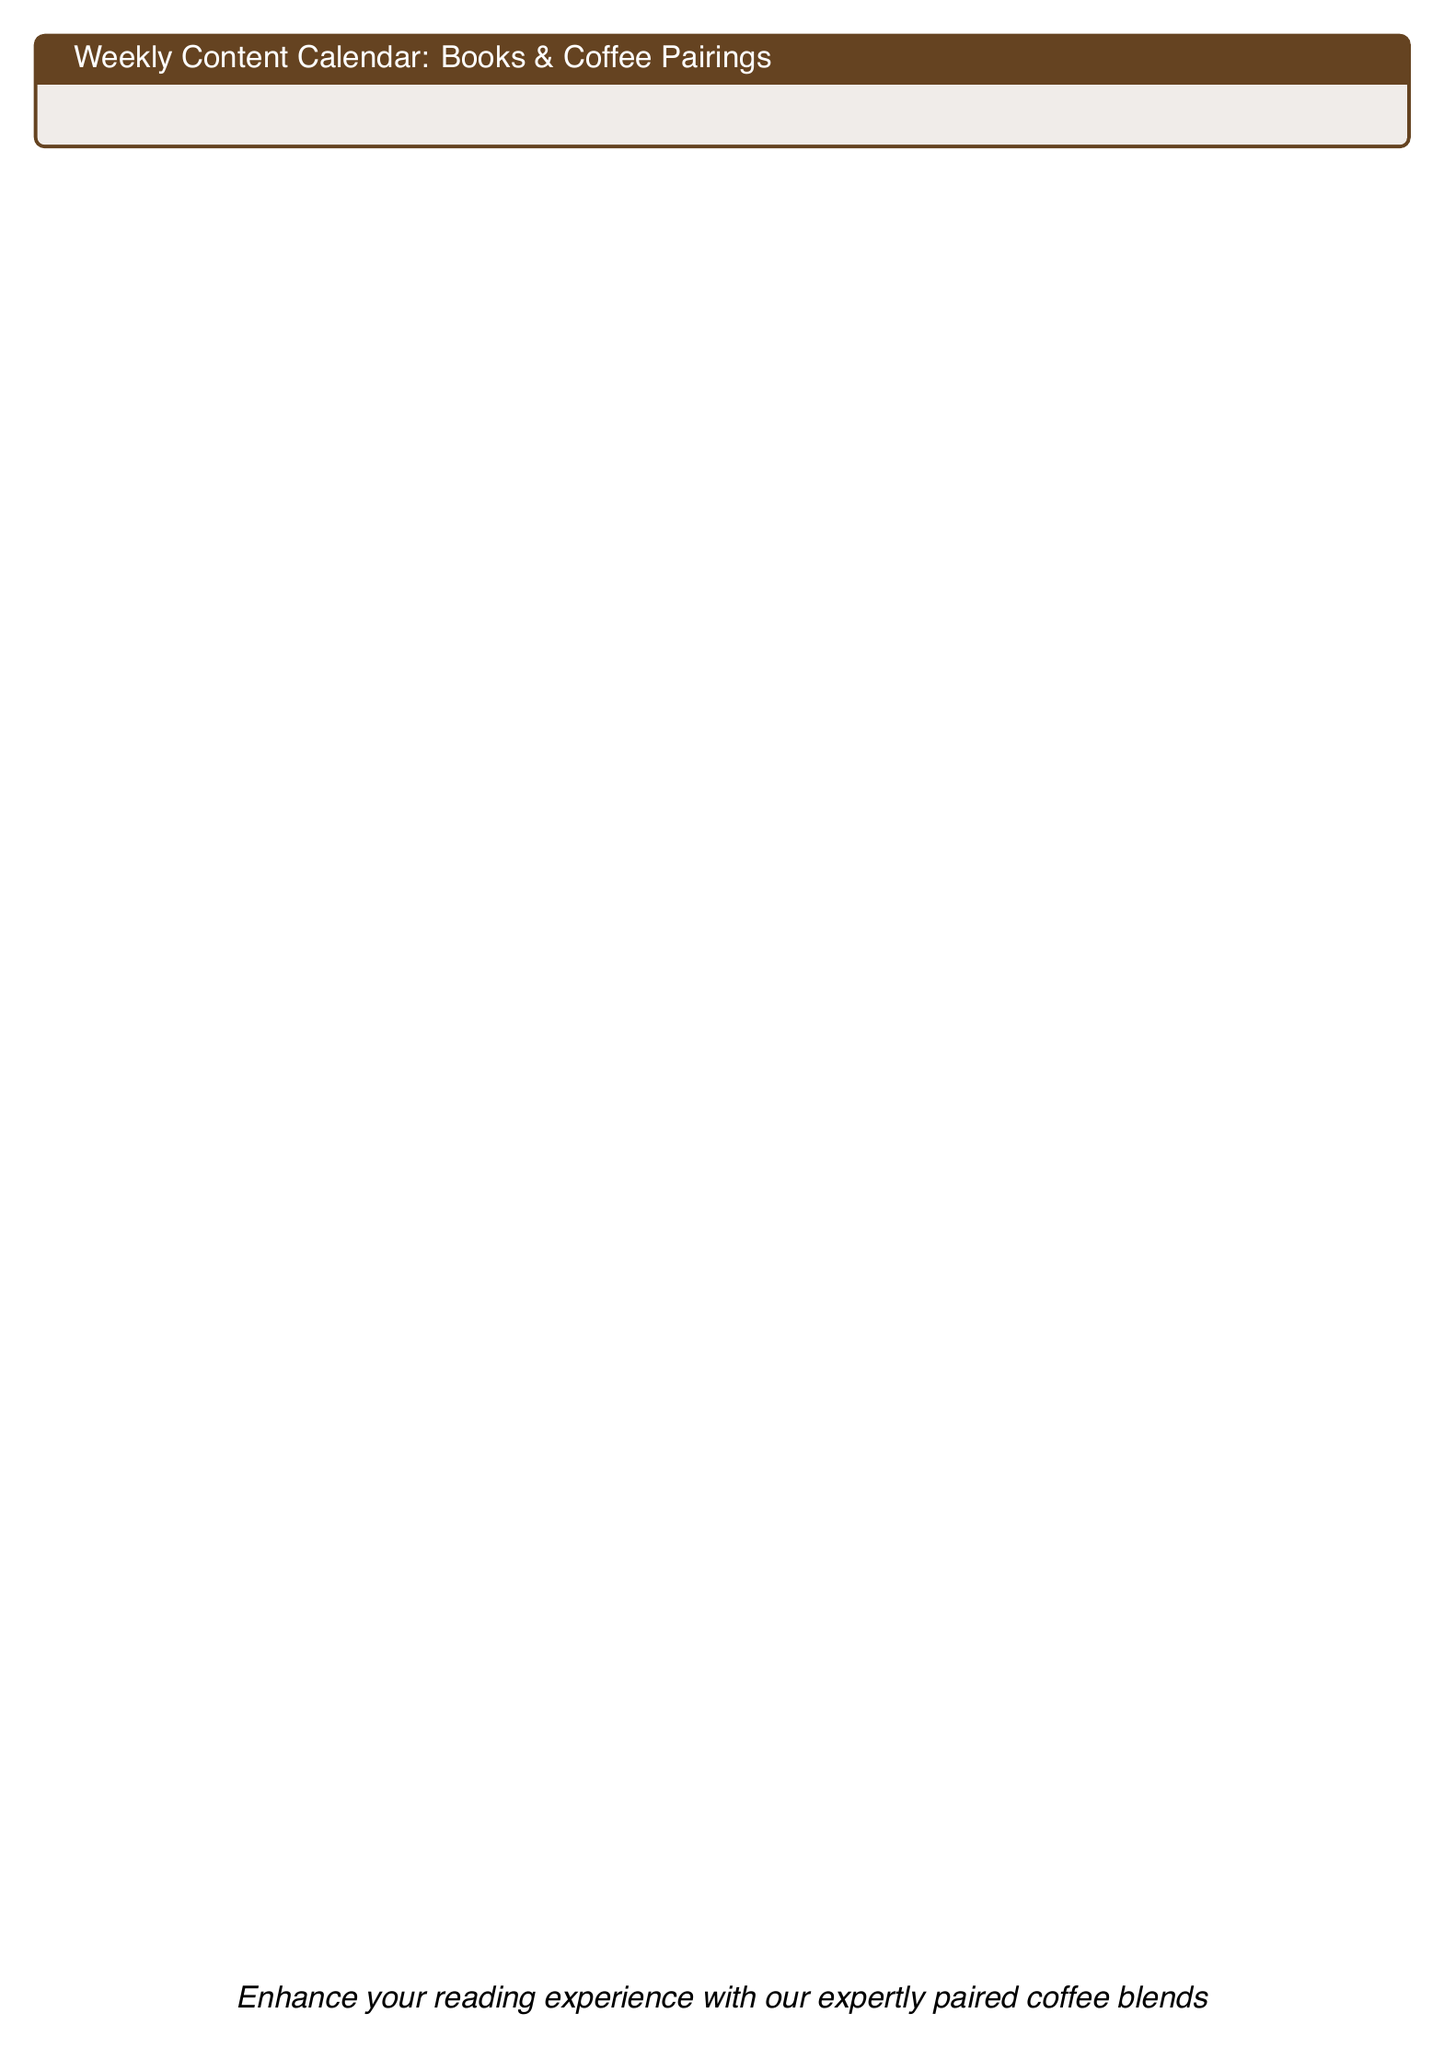What is the book pairing for Mystery Mondays? The document specifies that the book pairing for Mystery Mondays is "The Girl with the Dragon Tattoo."
Answer: The Girl with the Dragon Tattoo What coffee is recommended for Travel Tuesday? The document indicates that the coffee recommendation for Travel Tuesday is "Italian Espresso Blend."
Answer: Italian Espresso Blend Which day features "To Kill a Mockingbird"? The document lists "To Kill a Mockingbird" under Thursday, which is themed as Throwback Thursday.
Answer: Thursday What is the theme of Saturday? The document describes Saturday's theme as "Self-Care Saturday."
Answer: Self-Care Saturday What coffee is paired with The Alchemist? The document states that "The Alchemist" is paired with "Colombian Supremo."
Answer: Colombian Supremo Which coffee blend is associated with Wisdom Wednesday? According to the document, Wisdom Wednesday features "Ethiopian Yirgacheffe."
Answer: Ethiopian Yirgacheffe How many book pairings are there in total for the week? The document lists seven distinct book pairings from Monday to Sunday, one for each day of the week.
Answer: Seven What overall advice does the document provide for enhancing reading? The document concludes with the suggestion to enhance the reading experience with expertly paired coffee blends.
Answer: Expertly paired coffee blends 